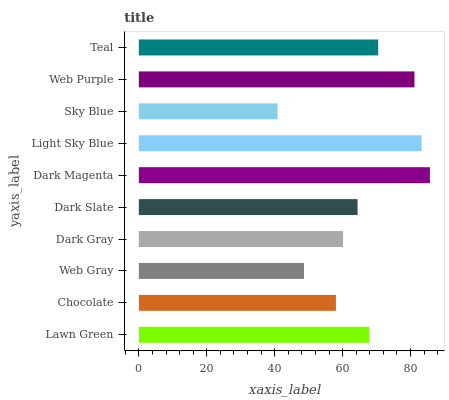Is Sky Blue the minimum?
Answer yes or no. Yes. Is Dark Magenta the maximum?
Answer yes or no. Yes. Is Chocolate the minimum?
Answer yes or no. No. Is Chocolate the maximum?
Answer yes or no. No. Is Lawn Green greater than Chocolate?
Answer yes or no. Yes. Is Chocolate less than Lawn Green?
Answer yes or no. Yes. Is Chocolate greater than Lawn Green?
Answer yes or no. No. Is Lawn Green less than Chocolate?
Answer yes or no. No. Is Lawn Green the high median?
Answer yes or no. Yes. Is Dark Slate the low median?
Answer yes or no. Yes. Is Chocolate the high median?
Answer yes or no. No. Is Lawn Green the low median?
Answer yes or no. No. 